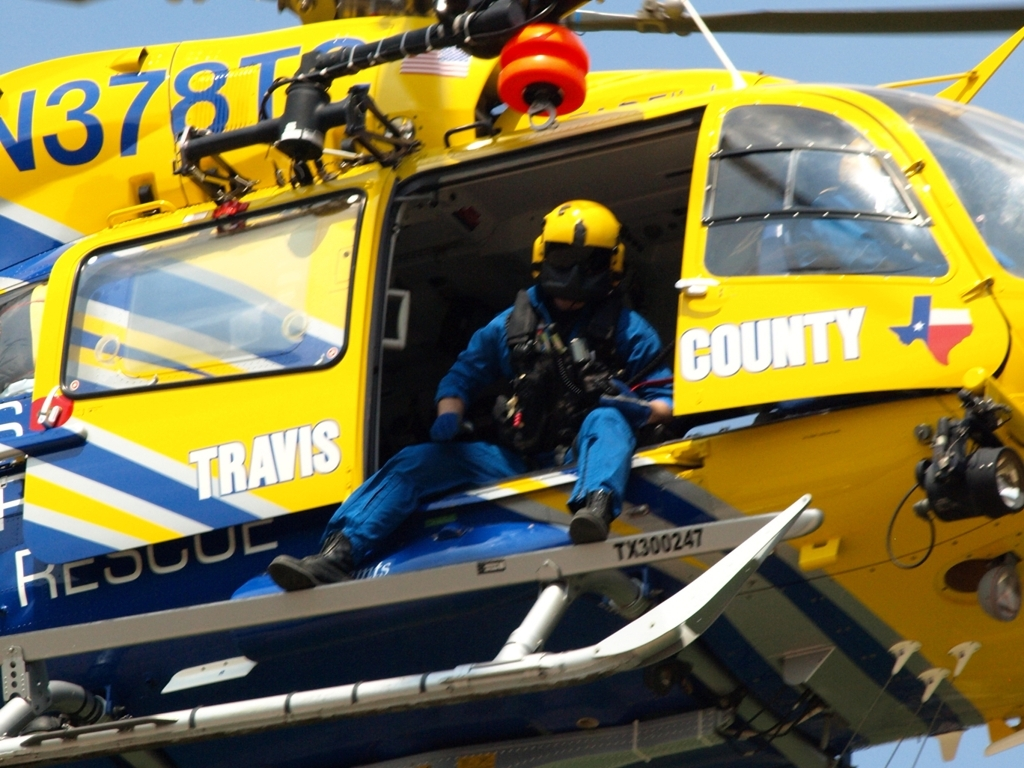Can you describe the action taking place and its possible context? The image captures a rescue operation in progress, depicted by a rescue worker in full gear preparing to disembark from a Travis County helicopter. The helicopter is likely to be hovering or preparing to land, which suggests that assistance is being provided in an area where a traditional vehicle would have difficulty accessing, possibly in response to an emergency or natural disaster. 